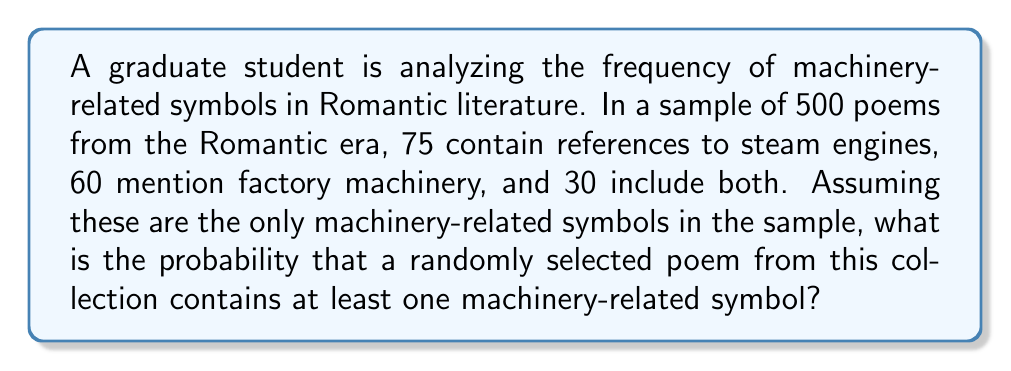Can you answer this question? To solve this problem, we'll use the concept of probability and set theory.

Let's define our events:
A: The poem contains a reference to steam engines
B: The poem mentions factory machinery

We're given:
n(A) = 75 (number of poems with steam engines)
n(B) = 60 (number of poems with factory machinery)
n(A ∩ B) = 30 (number of poems with both)
Total number of poems = 500

We need to find P(A ∪ B), the probability of a poem containing at least one machinery-related symbol.

Using the addition rule of probability:
P(A ∪ B) = P(A) + P(B) - P(A ∩ B)

First, let's calculate each probability:

P(A) = n(A) / Total = 75 / 500 = 0.15
P(B) = n(B) / Total = 60 / 500 = 0.12
P(A ∩ B) = n(A ∩ B) / Total = 30 / 500 = 0.06

Now, we can substitute these values into our formula:

P(A ∪ B) = P(A) + P(B) - P(A ∩ B)
         = 0.15 + 0.12 - 0.06
         = 0.21

Therefore, the probability that a randomly selected poem contains at least one machinery-related symbol is 0.21 or 21%.
Answer: The probability is 0.21 or 21%. 